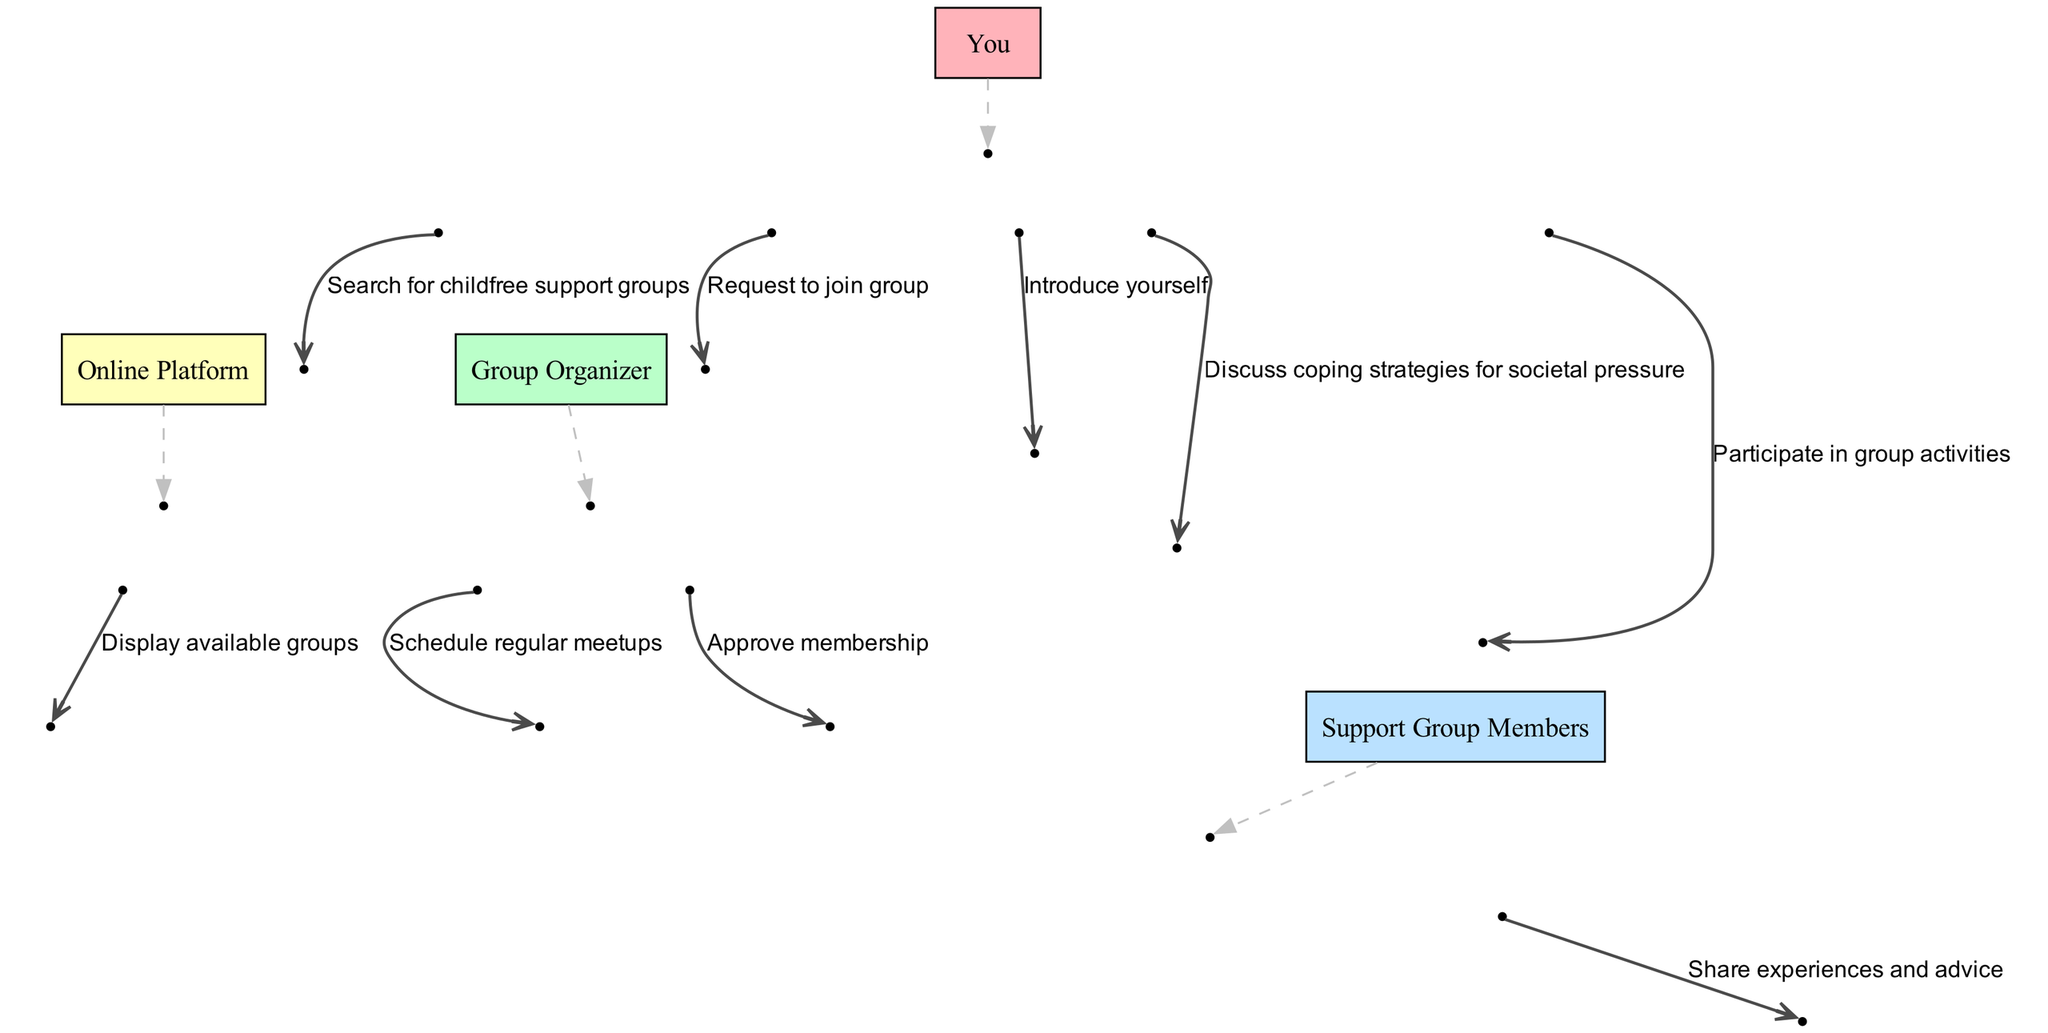What is the first action in the sequence? The first action listed in the diagram is "Search for childfree support groups," which is performed by "You" to the "Online Platform."
Answer: Search for childfree support groups Who approves the membership request? The membership request is approved by the "Group Organizer" as indicated in the action sequence between "You" and the "Group Organizer."
Answer: Group Organizer How many members are involved in the support group communication? There are three members involved: "You," "Group Organizer," and "Support Group Members," but directly, two parties communicate with each other in the actions.
Answer: Two What does "You" discuss with the support group members? "You" discuss "coping strategies for societal pressure" with the "Support Group Members," as shown in the message exchange in the diagram.
Answer: Coping strategies for societal pressure How many total actions take place in the sequence? By counting all the listed actions between the actors, a total of eight actions are present within the sequence diagram.
Answer: Eight Which actor is responsible for scheduling regular meetups? The "Group Organizer" is responsible for scheduling regular meetups, as indicated in the directed action in the diagram.
Answer: Group Organizer What type of interactions occur between "You" and "Support Group Members"? The interactions between "You" and "Support Group Members" involve introducing oneself, sharing experiences and advice, and discussing coping strategies.
Answer: Multiple interactions What does the action from "Support Group Members" entail? The action from "Support Group Members" involves them sharing experiences and advice with "You," as indicated in the diagram sequence.
Answer: Share experiences and advice 